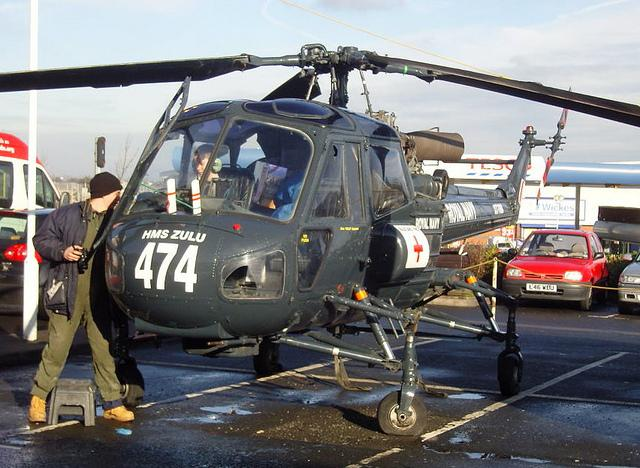What kind of chopper is this? rescue 